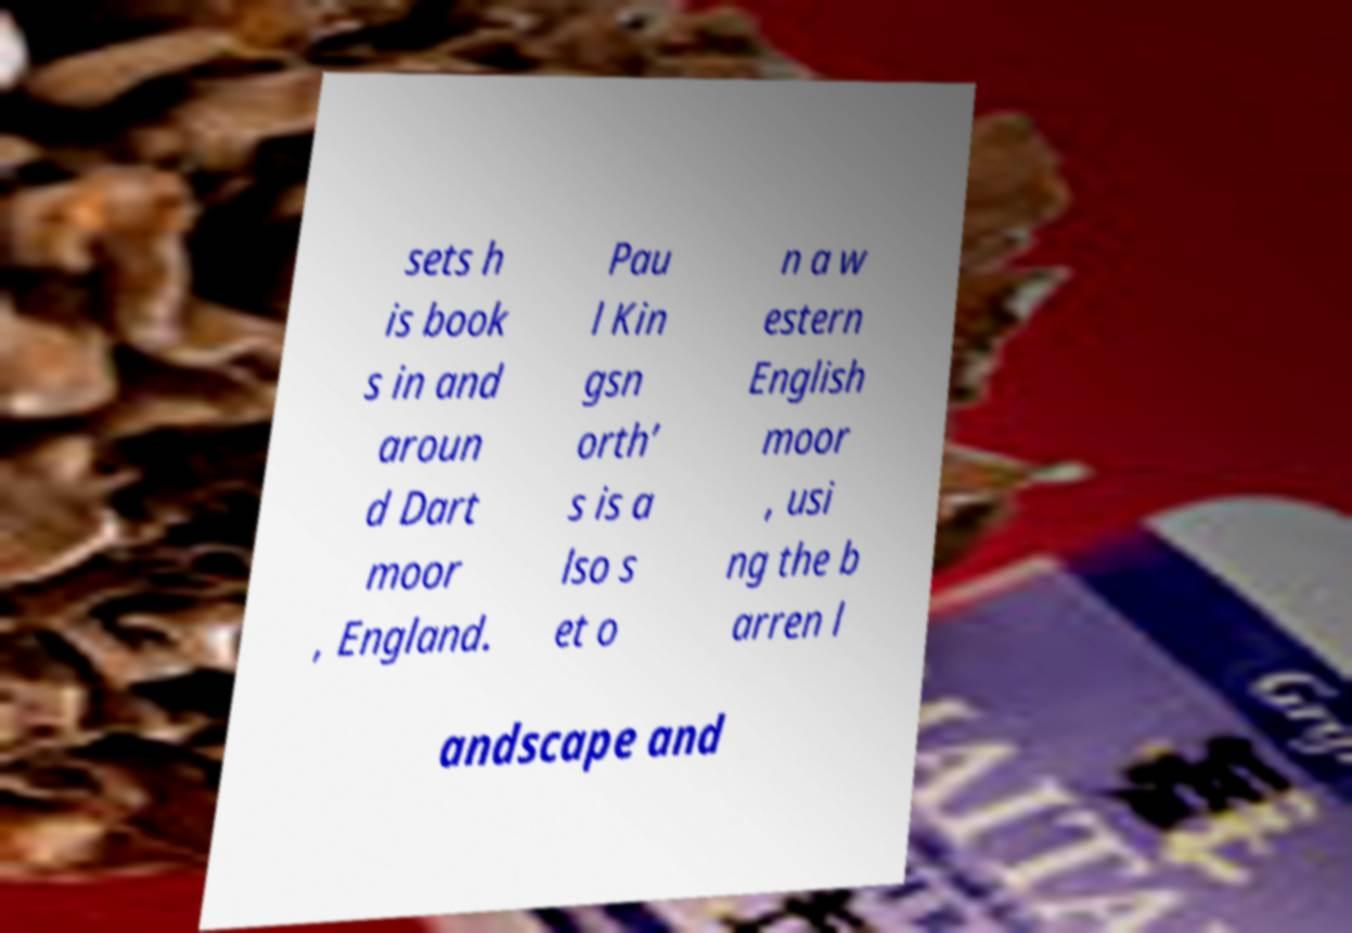For documentation purposes, I need the text within this image transcribed. Could you provide that? sets h is book s in and aroun d Dart moor , England. Pau l Kin gsn orth’ s is a lso s et o n a w estern English moor , usi ng the b arren l andscape and 